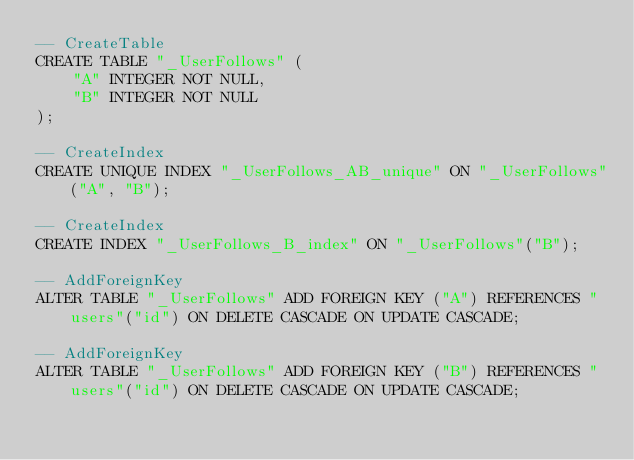Convert code to text. <code><loc_0><loc_0><loc_500><loc_500><_SQL_>-- CreateTable
CREATE TABLE "_UserFollows" (
    "A" INTEGER NOT NULL,
    "B" INTEGER NOT NULL
);

-- CreateIndex
CREATE UNIQUE INDEX "_UserFollows_AB_unique" ON "_UserFollows"("A", "B");

-- CreateIndex
CREATE INDEX "_UserFollows_B_index" ON "_UserFollows"("B");

-- AddForeignKey
ALTER TABLE "_UserFollows" ADD FOREIGN KEY ("A") REFERENCES "users"("id") ON DELETE CASCADE ON UPDATE CASCADE;

-- AddForeignKey
ALTER TABLE "_UserFollows" ADD FOREIGN KEY ("B") REFERENCES "users"("id") ON DELETE CASCADE ON UPDATE CASCADE;
</code> 